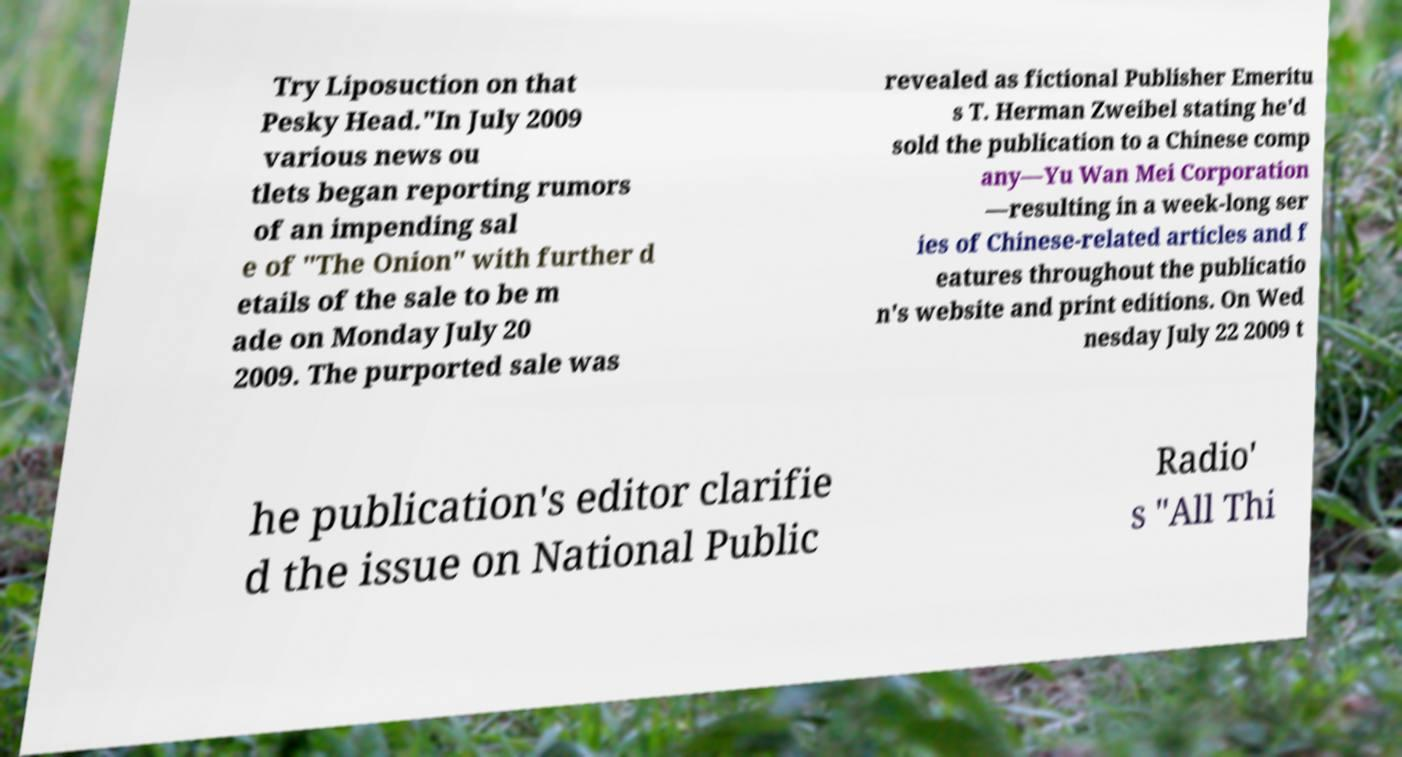Can you accurately transcribe the text from the provided image for me? Try Liposuction on that Pesky Head."In July 2009 various news ou tlets began reporting rumors of an impending sal e of "The Onion" with further d etails of the sale to be m ade on Monday July 20 2009. The purported sale was revealed as fictional Publisher Emeritu s T. Herman Zweibel stating he'd sold the publication to a Chinese comp any—Yu Wan Mei Corporation —resulting in a week-long ser ies of Chinese-related articles and f eatures throughout the publicatio n's website and print editions. On Wed nesday July 22 2009 t he publication's editor clarifie d the issue on National Public Radio' s "All Thi 